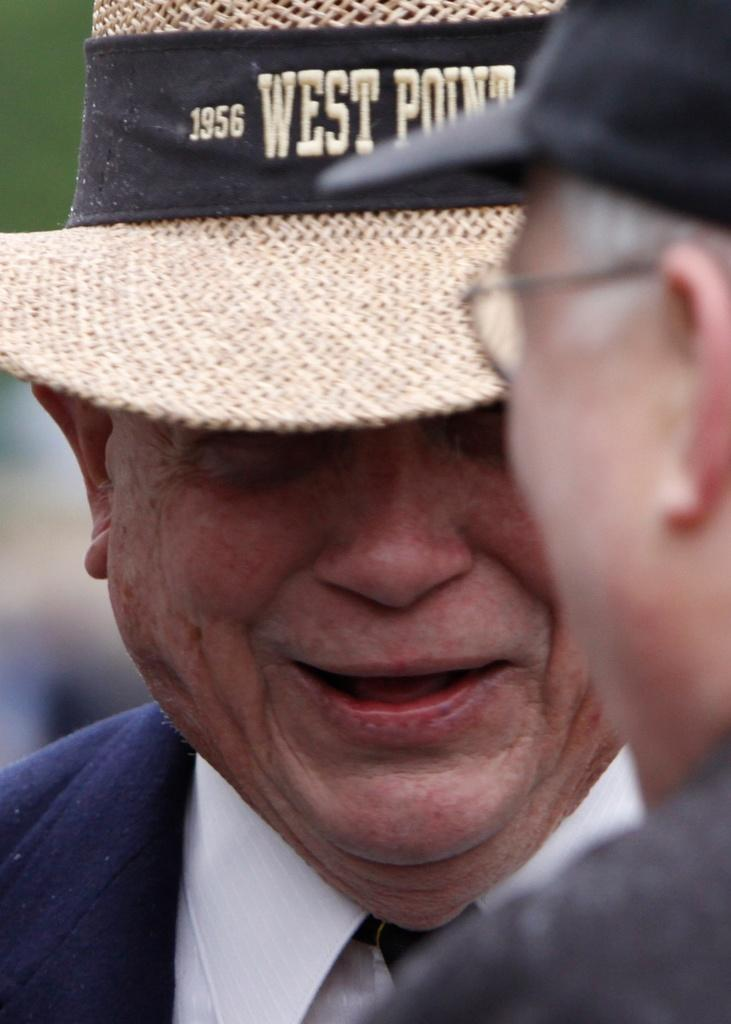How many people are present in the image? There are two people in the image. What are the people wearing on their heads? Both people are wearing hats. Can you describe the background of the image? The background of the image is blurry. What type of board can be seen being used by the people in the image? There is no board present in the image; the people are wearing hats and standing in a blurry background. 